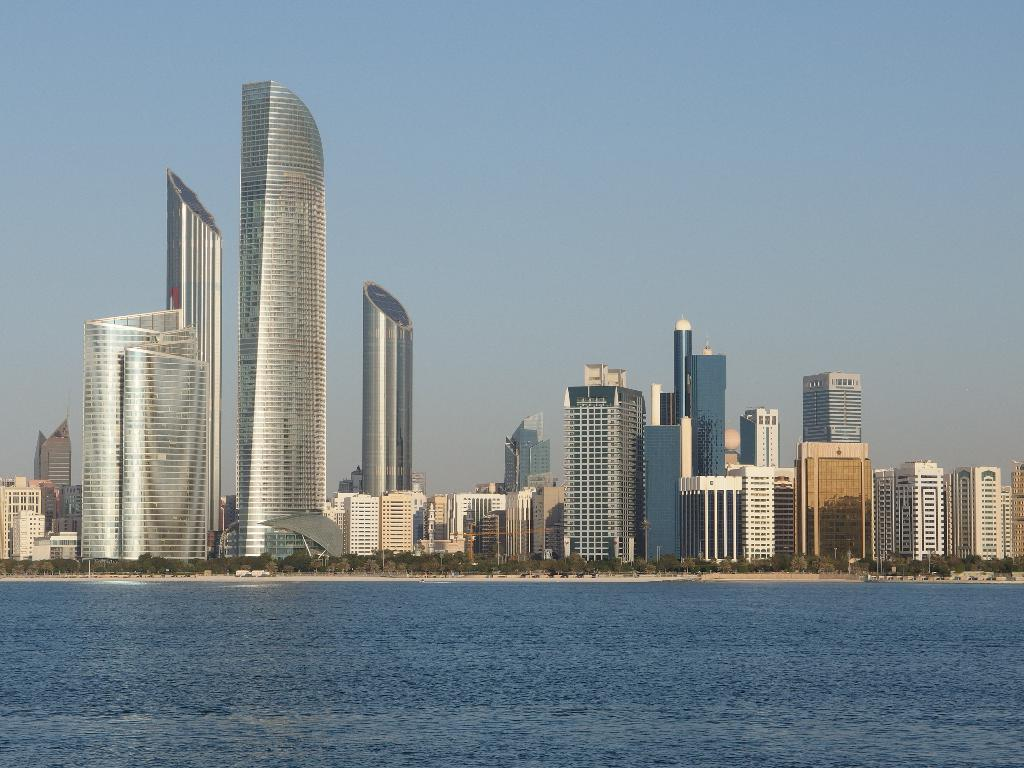What is the primary element visible in the image? There is water in the image. What type of natural vegetation can be seen in the image? There are trees visible in the image. What type of man-made structures are present in the image? There are buildings in the image. What type of tooth is visible in the image? There is no tooth present in the image. What type of sticks can be seen in the image? There are no sticks visible in the image. 